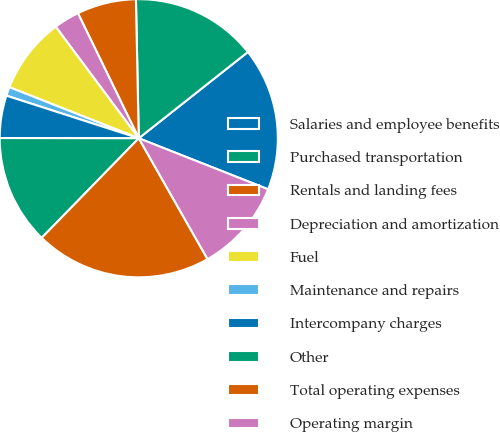<chart> <loc_0><loc_0><loc_500><loc_500><pie_chart><fcel>Salaries and employee benefits<fcel>Purchased transportation<fcel>Rentals and landing fees<fcel>Depreciation and amortization<fcel>Fuel<fcel>Maintenance and repairs<fcel>Intercompany charges<fcel>Other<fcel>Total operating expenses<fcel>Operating margin<nl><fcel>16.63%<fcel>14.68%<fcel>6.88%<fcel>2.98%<fcel>8.83%<fcel>1.03%<fcel>4.93%<fcel>12.73%<fcel>20.53%<fcel>10.78%<nl></chart> 